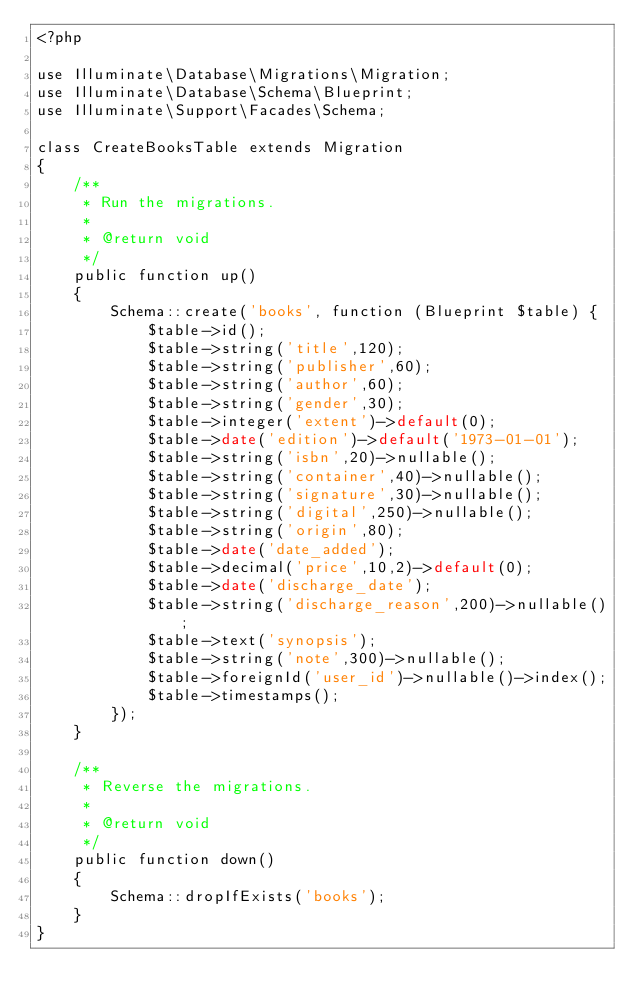Convert code to text. <code><loc_0><loc_0><loc_500><loc_500><_PHP_><?php

use Illuminate\Database\Migrations\Migration;
use Illuminate\Database\Schema\Blueprint;
use Illuminate\Support\Facades\Schema;

class CreateBooksTable extends Migration
{
    /**
     * Run the migrations.
     *
     * @return void
     */
    public function up()
    {
        Schema::create('books', function (Blueprint $table) {
            $table->id();
            $table->string('title',120);
            $table->string('publisher',60);
            $table->string('author',60);
            $table->string('gender',30);
            $table->integer('extent')->default(0);
            $table->date('edition')->default('1973-01-01');
            $table->string('isbn',20)->nullable();
            $table->string('container',40)->nullable();
            $table->string('signature',30)->nullable();
            $table->string('digital',250)->nullable();
            $table->string('origin',80);
            $table->date('date_added');
            $table->decimal('price',10,2)->default(0);
            $table->date('discharge_date');
            $table->string('discharge_reason',200)->nullable();
            $table->text('synopsis');
            $table->string('note',300)->nullable();
            $table->foreignId('user_id')->nullable()->index();
            $table->timestamps();
        });
    }

    /**
     * Reverse the migrations.
     *
     * @return void
     */
    public function down()
    {
        Schema::dropIfExists('books');
    }
}
</code> 